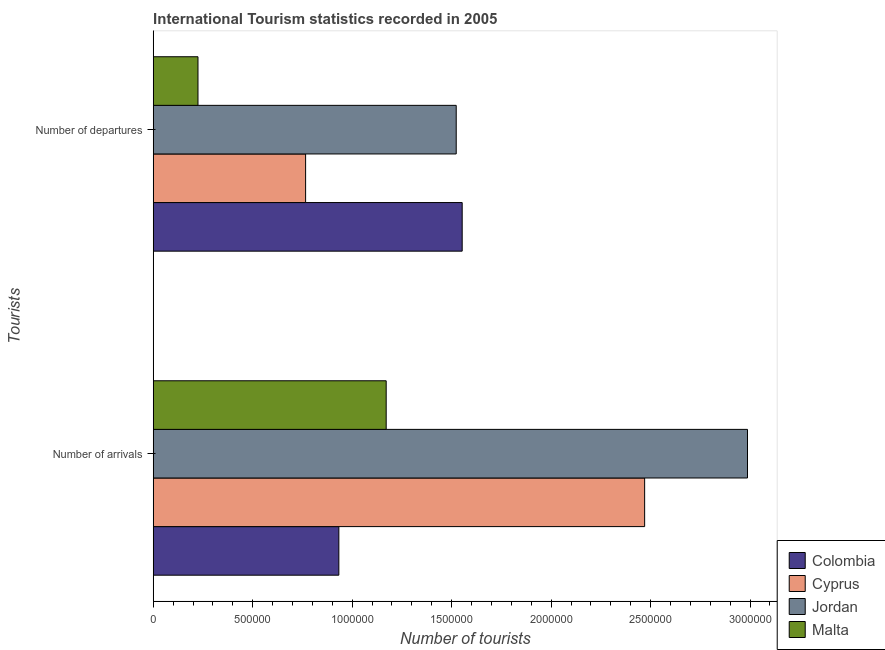How many groups of bars are there?
Your response must be concise. 2. How many bars are there on the 1st tick from the top?
Make the answer very short. 4. What is the label of the 1st group of bars from the top?
Keep it short and to the point. Number of departures. What is the number of tourist arrivals in Jordan?
Keep it short and to the point. 2.99e+06. Across all countries, what is the maximum number of tourist arrivals?
Provide a succinct answer. 2.99e+06. Across all countries, what is the minimum number of tourist departures?
Ensure brevity in your answer.  2.25e+05. In which country was the number of tourist arrivals maximum?
Keep it short and to the point. Jordan. In which country was the number of tourist departures minimum?
Offer a very short reply. Malta. What is the total number of tourist arrivals in the graph?
Give a very brief answer. 7.56e+06. What is the difference between the number of tourist departures in Cyprus and that in Jordan?
Your answer should be very brief. -7.57e+05. What is the difference between the number of tourist departures in Malta and the number of tourist arrivals in Cyprus?
Provide a succinct answer. -2.24e+06. What is the average number of tourist arrivals per country?
Offer a very short reply. 1.89e+06. What is the difference between the number of tourist arrivals and number of tourist departures in Colombia?
Give a very brief answer. -6.20e+05. In how many countries, is the number of tourist departures greater than 2300000 ?
Provide a succinct answer. 0. What is the ratio of the number of tourist departures in Malta to that in Jordan?
Ensure brevity in your answer.  0.15. Is the number of tourist arrivals in Colombia less than that in Cyprus?
Offer a very short reply. Yes. What does the 3rd bar from the top in Number of departures represents?
Your response must be concise. Cyprus. What does the 4th bar from the bottom in Number of arrivals represents?
Offer a very short reply. Malta. How many countries are there in the graph?
Give a very brief answer. 4. What is the difference between two consecutive major ticks on the X-axis?
Provide a short and direct response. 5.00e+05. How many legend labels are there?
Provide a succinct answer. 4. How are the legend labels stacked?
Provide a succinct answer. Vertical. What is the title of the graph?
Offer a very short reply. International Tourism statistics recorded in 2005. What is the label or title of the X-axis?
Offer a terse response. Number of tourists. What is the label or title of the Y-axis?
Offer a terse response. Tourists. What is the Number of tourists of Colombia in Number of arrivals?
Your answer should be very brief. 9.33e+05. What is the Number of tourists in Cyprus in Number of arrivals?
Your response must be concise. 2.47e+06. What is the Number of tourists in Jordan in Number of arrivals?
Make the answer very short. 2.99e+06. What is the Number of tourists of Malta in Number of arrivals?
Give a very brief answer. 1.17e+06. What is the Number of tourists in Colombia in Number of departures?
Your answer should be very brief. 1.55e+06. What is the Number of tourists in Cyprus in Number of departures?
Your response must be concise. 7.66e+05. What is the Number of tourists in Jordan in Number of departures?
Your response must be concise. 1.52e+06. What is the Number of tourists of Malta in Number of departures?
Give a very brief answer. 2.25e+05. Across all Tourists, what is the maximum Number of tourists of Colombia?
Your answer should be compact. 1.55e+06. Across all Tourists, what is the maximum Number of tourists of Cyprus?
Give a very brief answer. 2.47e+06. Across all Tourists, what is the maximum Number of tourists of Jordan?
Keep it short and to the point. 2.99e+06. Across all Tourists, what is the maximum Number of tourists of Malta?
Give a very brief answer. 1.17e+06. Across all Tourists, what is the minimum Number of tourists in Colombia?
Provide a short and direct response. 9.33e+05. Across all Tourists, what is the minimum Number of tourists of Cyprus?
Your answer should be very brief. 7.66e+05. Across all Tourists, what is the minimum Number of tourists in Jordan?
Offer a terse response. 1.52e+06. Across all Tourists, what is the minimum Number of tourists in Malta?
Offer a terse response. 2.25e+05. What is the total Number of tourists of Colombia in the graph?
Provide a short and direct response. 2.49e+06. What is the total Number of tourists in Cyprus in the graph?
Keep it short and to the point. 3.24e+06. What is the total Number of tourists of Jordan in the graph?
Your answer should be compact. 4.51e+06. What is the total Number of tourists of Malta in the graph?
Ensure brevity in your answer.  1.40e+06. What is the difference between the Number of tourists of Colombia in Number of arrivals and that in Number of departures?
Provide a succinct answer. -6.20e+05. What is the difference between the Number of tourists of Cyprus in Number of arrivals and that in Number of departures?
Give a very brief answer. 1.70e+06. What is the difference between the Number of tourists in Jordan in Number of arrivals and that in Number of departures?
Your answer should be compact. 1.46e+06. What is the difference between the Number of tourists in Malta in Number of arrivals and that in Number of departures?
Keep it short and to the point. 9.46e+05. What is the difference between the Number of tourists in Colombia in Number of arrivals and the Number of tourists in Cyprus in Number of departures?
Offer a very short reply. 1.67e+05. What is the difference between the Number of tourists in Colombia in Number of arrivals and the Number of tourists in Jordan in Number of departures?
Offer a very short reply. -5.90e+05. What is the difference between the Number of tourists of Colombia in Number of arrivals and the Number of tourists of Malta in Number of departures?
Offer a very short reply. 7.08e+05. What is the difference between the Number of tourists in Cyprus in Number of arrivals and the Number of tourists in Jordan in Number of departures?
Offer a very short reply. 9.47e+05. What is the difference between the Number of tourists in Cyprus in Number of arrivals and the Number of tourists in Malta in Number of departures?
Offer a very short reply. 2.24e+06. What is the difference between the Number of tourists in Jordan in Number of arrivals and the Number of tourists in Malta in Number of departures?
Give a very brief answer. 2.76e+06. What is the average Number of tourists of Colombia per Tourists?
Your response must be concise. 1.24e+06. What is the average Number of tourists in Cyprus per Tourists?
Offer a terse response. 1.62e+06. What is the average Number of tourists of Jordan per Tourists?
Your response must be concise. 2.26e+06. What is the average Number of tourists in Malta per Tourists?
Your answer should be compact. 6.98e+05. What is the difference between the Number of tourists in Colombia and Number of tourists in Cyprus in Number of arrivals?
Give a very brief answer. -1.54e+06. What is the difference between the Number of tourists of Colombia and Number of tourists of Jordan in Number of arrivals?
Your response must be concise. -2.05e+06. What is the difference between the Number of tourists of Colombia and Number of tourists of Malta in Number of arrivals?
Ensure brevity in your answer.  -2.38e+05. What is the difference between the Number of tourists in Cyprus and Number of tourists in Jordan in Number of arrivals?
Give a very brief answer. -5.17e+05. What is the difference between the Number of tourists of Cyprus and Number of tourists of Malta in Number of arrivals?
Offer a terse response. 1.30e+06. What is the difference between the Number of tourists of Jordan and Number of tourists of Malta in Number of arrivals?
Keep it short and to the point. 1.82e+06. What is the difference between the Number of tourists of Colombia and Number of tourists of Cyprus in Number of departures?
Make the answer very short. 7.87e+05. What is the difference between the Number of tourists of Colombia and Number of tourists of Malta in Number of departures?
Ensure brevity in your answer.  1.33e+06. What is the difference between the Number of tourists of Cyprus and Number of tourists of Jordan in Number of departures?
Keep it short and to the point. -7.57e+05. What is the difference between the Number of tourists of Cyprus and Number of tourists of Malta in Number of departures?
Offer a very short reply. 5.41e+05. What is the difference between the Number of tourists in Jordan and Number of tourists in Malta in Number of departures?
Provide a succinct answer. 1.30e+06. What is the ratio of the Number of tourists in Colombia in Number of arrivals to that in Number of departures?
Keep it short and to the point. 0.6. What is the ratio of the Number of tourists in Cyprus in Number of arrivals to that in Number of departures?
Keep it short and to the point. 3.22. What is the ratio of the Number of tourists in Jordan in Number of arrivals to that in Number of departures?
Your response must be concise. 1.96. What is the ratio of the Number of tourists in Malta in Number of arrivals to that in Number of departures?
Make the answer very short. 5.2. What is the difference between the highest and the second highest Number of tourists of Colombia?
Provide a succinct answer. 6.20e+05. What is the difference between the highest and the second highest Number of tourists in Cyprus?
Give a very brief answer. 1.70e+06. What is the difference between the highest and the second highest Number of tourists in Jordan?
Your response must be concise. 1.46e+06. What is the difference between the highest and the second highest Number of tourists of Malta?
Offer a very short reply. 9.46e+05. What is the difference between the highest and the lowest Number of tourists of Colombia?
Provide a short and direct response. 6.20e+05. What is the difference between the highest and the lowest Number of tourists of Cyprus?
Provide a short and direct response. 1.70e+06. What is the difference between the highest and the lowest Number of tourists in Jordan?
Your answer should be very brief. 1.46e+06. What is the difference between the highest and the lowest Number of tourists of Malta?
Give a very brief answer. 9.46e+05. 